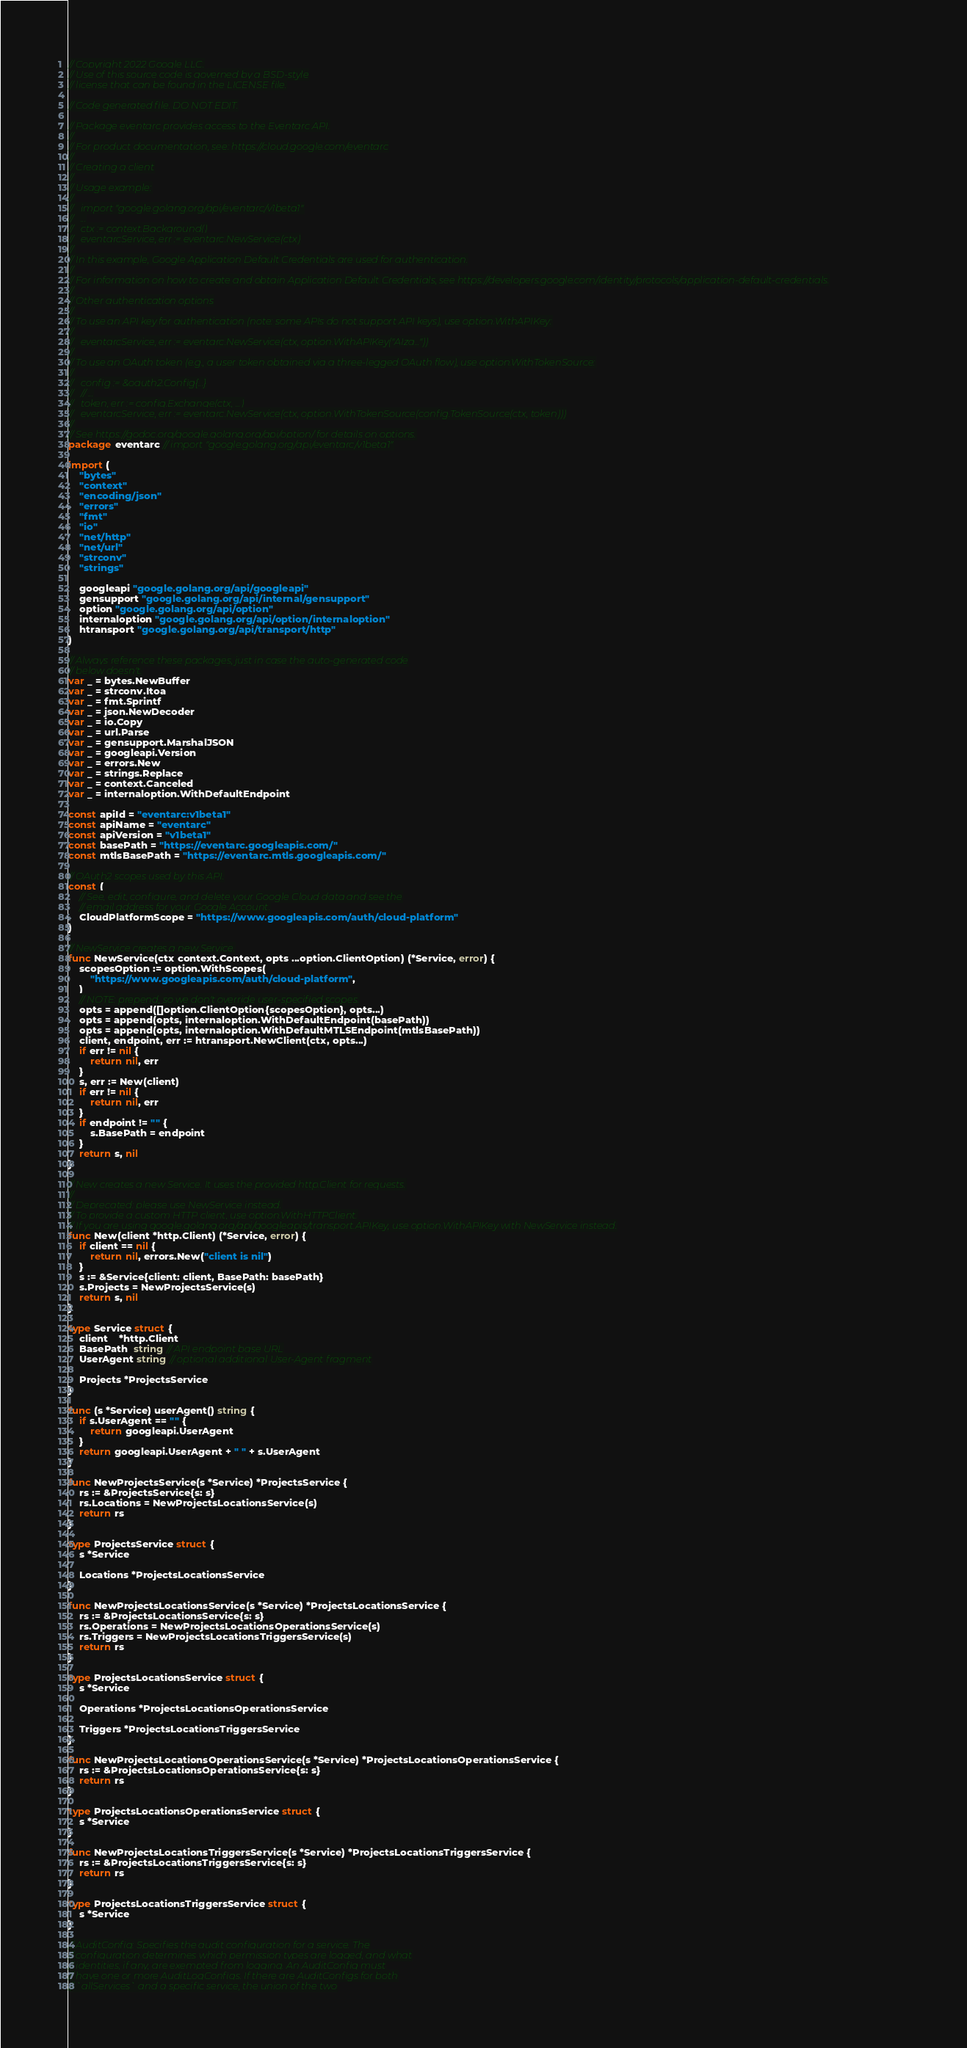<code> <loc_0><loc_0><loc_500><loc_500><_Go_>// Copyright 2022 Google LLC.
// Use of this source code is governed by a BSD-style
// license that can be found in the LICENSE file.

// Code generated file. DO NOT EDIT.

// Package eventarc provides access to the Eventarc API.
//
// For product documentation, see: https://cloud.google.com/eventarc
//
// Creating a client
//
// Usage example:
//
//   import "google.golang.org/api/eventarc/v1beta1"
//   ...
//   ctx := context.Background()
//   eventarcService, err := eventarc.NewService(ctx)
//
// In this example, Google Application Default Credentials are used for authentication.
//
// For information on how to create and obtain Application Default Credentials, see https://developers.google.com/identity/protocols/application-default-credentials.
//
// Other authentication options
//
// To use an API key for authentication (note: some APIs do not support API keys), use option.WithAPIKey:
//
//   eventarcService, err := eventarc.NewService(ctx, option.WithAPIKey("AIza..."))
//
// To use an OAuth token (e.g., a user token obtained via a three-legged OAuth flow), use option.WithTokenSource:
//
//   config := &oauth2.Config{...}
//   // ...
//   token, err := config.Exchange(ctx, ...)
//   eventarcService, err := eventarc.NewService(ctx, option.WithTokenSource(config.TokenSource(ctx, token)))
//
// See https://godoc.org/google.golang.org/api/option/ for details on options.
package eventarc // import "google.golang.org/api/eventarc/v1beta1"

import (
	"bytes"
	"context"
	"encoding/json"
	"errors"
	"fmt"
	"io"
	"net/http"
	"net/url"
	"strconv"
	"strings"

	googleapi "google.golang.org/api/googleapi"
	gensupport "google.golang.org/api/internal/gensupport"
	option "google.golang.org/api/option"
	internaloption "google.golang.org/api/option/internaloption"
	htransport "google.golang.org/api/transport/http"
)

// Always reference these packages, just in case the auto-generated code
// below doesn't.
var _ = bytes.NewBuffer
var _ = strconv.Itoa
var _ = fmt.Sprintf
var _ = json.NewDecoder
var _ = io.Copy
var _ = url.Parse
var _ = gensupport.MarshalJSON
var _ = googleapi.Version
var _ = errors.New
var _ = strings.Replace
var _ = context.Canceled
var _ = internaloption.WithDefaultEndpoint

const apiId = "eventarc:v1beta1"
const apiName = "eventarc"
const apiVersion = "v1beta1"
const basePath = "https://eventarc.googleapis.com/"
const mtlsBasePath = "https://eventarc.mtls.googleapis.com/"

// OAuth2 scopes used by this API.
const (
	// See, edit, configure, and delete your Google Cloud data and see the
	// email address for your Google Account.
	CloudPlatformScope = "https://www.googleapis.com/auth/cloud-platform"
)

// NewService creates a new Service.
func NewService(ctx context.Context, opts ...option.ClientOption) (*Service, error) {
	scopesOption := option.WithScopes(
		"https://www.googleapis.com/auth/cloud-platform",
	)
	// NOTE: prepend, so we don't override user-specified scopes.
	opts = append([]option.ClientOption{scopesOption}, opts...)
	opts = append(opts, internaloption.WithDefaultEndpoint(basePath))
	opts = append(opts, internaloption.WithDefaultMTLSEndpoint(mtlsBasePath))
	client, endpoint, err := htransport.NewClient(ctx, opts...)
	if err != nil {
		return nil, err
	}
	s, err := New(client)
	if err != nil {
		return nil, err
	}
	if endpoint != "" {
		s.BasePath = endpoint
	}
	return s, nil
}

// New creates a new Service. It uses the provided http.Client for requests.
//
// Deprecated: please use NewService instead.
// To provide a custom HTTP client, use option.WithHTTPClient.
// If you are using google.golang.org/api/googleapis/transport.APIKey, use option.WithAPIKey with NewService instead.
func New(client *http.Client) (*Service, error) {
	if client == nil {
		return nil, errors.New("client is nil")
	}
	s := &Service{client: client, BasePath: basePath}
	s.Projects = NewProjectsService(s)
	return s, nil
}

type Service struct {
	client    *http.Client
	BasePath  string // API endpoint base URL
	UserAgent string // optional additional User-Agent fragment

	Projects *ProjectsService
}

func (s *Service) userAgent() string {
	if s.UserAgent == "" {
		return googleapi.UserAgent
	}
	return googleapi.UserAgent + " " + s.UserAgent
}

func NewProjectsService(s *Service) *ProjectsService {
	rs := &ProjectsService{s: s}
	rs.Locations = NewProjectsLocationsService(s)
	return rs
}

type ProjectsService struct {
	s *Service

	Locations *ProjectsLocationsService
}

func NewProjectsLocationsService(s *Service) *ProjectsLocationsService {
	rs := &ProjectsLocationsService{s: s}
	rs.Operations = NewProjectsLocationsOperationsService(s)
	rs.Triggers = NewProjectsLocationsTriggersService(s)
	return rs
}

type ProjectsLocationsService struct {
	s *Service

	Operations *ProjectsLocationsOperationsService

	Triggers *ProjectsLocationsTriggersService
}

func NewProjectsLocationsOperationsService(s *Service) *ProjectsLocationsOperationsService {
	rs := &ProjectsLocationsOperationsService{s: s}
	return rs
}

type ProjectsLocationsOperationsService struct {
	s *Service
}

func NewProjectsLocationsTriggersService(s *Service) *ProjectsLocationsTriggersService {
	rs := &ProjectsLocationsTriggersService{s: s}
	return rs
}

type ProjectsLocationsTriggersService struct {
	s *Service
}

// AuditConfig: Specifies the audit configuration for a service. The
// configuration determines which permission types are logged, and what
// identities, if any, are exempted from logging. An AuditConfig must
// have one or more AuditLogConfigs. If there are AuditConfigs for both
// `allServices` and a specific service, the union of the two</code> 